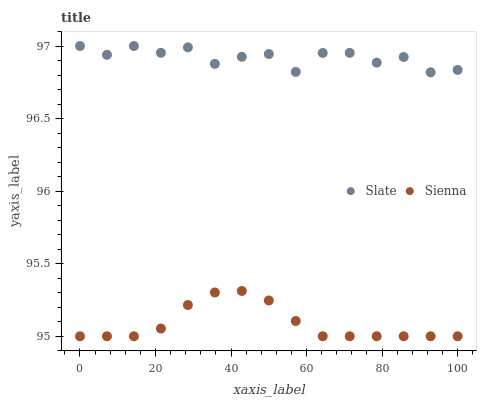Does Sienna have the minimum area under the curve?
Answer yes or no. Yes. Does Slate have the maximum area under the curve?
Answer yes or no. Yes. Does Slate have the minimum area under the curve?
Answer yes or no. No. Is Sienna the smoothest?
Answer yes or no. Yes. Is Slate the roughest?
Answer yes or no. Yes. Is Slate the smoothest?
Answer yes or no. No. Does Sienna have the lowest value?
Answer yes or no. Yes. Does Slate have the lowest value?
Answer yes or no. No. Does Slate have the highest value?
Answer yes or no. Yes. Is Sienna less than Slate?
Answer yes or no. Yes. Is Slate greater than Sienna?
Answer yes or no. Yes. Does Sienna intersect Slate?
Answer yes or no. No. 